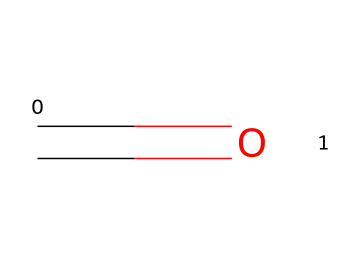What is the chemical formula of formaldehyde? The chemical structure represented by the SMILES notation includes one carbon atom (C) and one oxygen atom (O), which together create the formula CH2O.
Answer: CH2O How many hydrogen atoms are in formaldehyde? In the chemical structure represented, there are two hydrogen atoms connected to the carbon atom (C), making the total number of hydrogen atoms two.
Answer: 2 What type of bond exists between carbon and oxygen in formaldehyde? The structure indicates that there is a double bond between the carbon (C) and oxygen (O) atoms, as shown by the equal sign (=) in the SMILES notation.
Answer: double bond Is formaldehyde a saturated or unsaturated compound? The presence of a double bond in the structure indicates that formaldehyde has unsaturation, which classifies it as an unsaturated compound.
Answer: unsaturated What hazardous effect is commonly associated with formaldehyde exposure? Exposure to formaldehyde is often linked to respiratory issues and irritation, making it a known irritant in various health contexts.
Answer: irritant What role does formaldehyde play in a healthcare setting? Formaldehyde is primarily used as a disinfectant in healthcare settings due to its ability to kill germs and preserve biological specimens.
Answer: disinfectant 